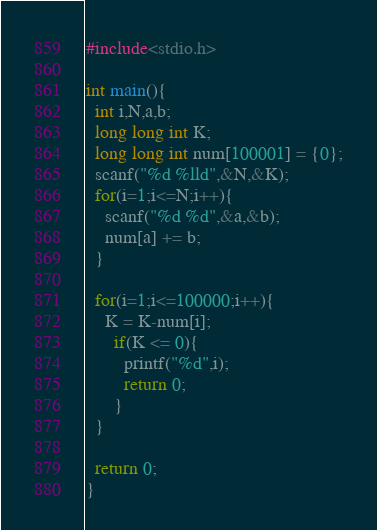Convert code to text. <code><loc_0><loc_0><loc_500><loc_500><_C_>#include<stdio.h>

int main(){
  int i,N,a,b;
  long long int K;
  long long int num[100001] = {0};
  scanf("%d %lld",&N,&K);
  for(i=1;i<=N;i++){
    scanf("%d %d",&a,&b);
    num[a] += b;
  }
 
  for(i=1;i<=100000;i++){
    K = K-num[i];
      if(K <= 0){
        printf("%d",i);
        return 0;
      }
  }
  
  return 0;
}</code> 